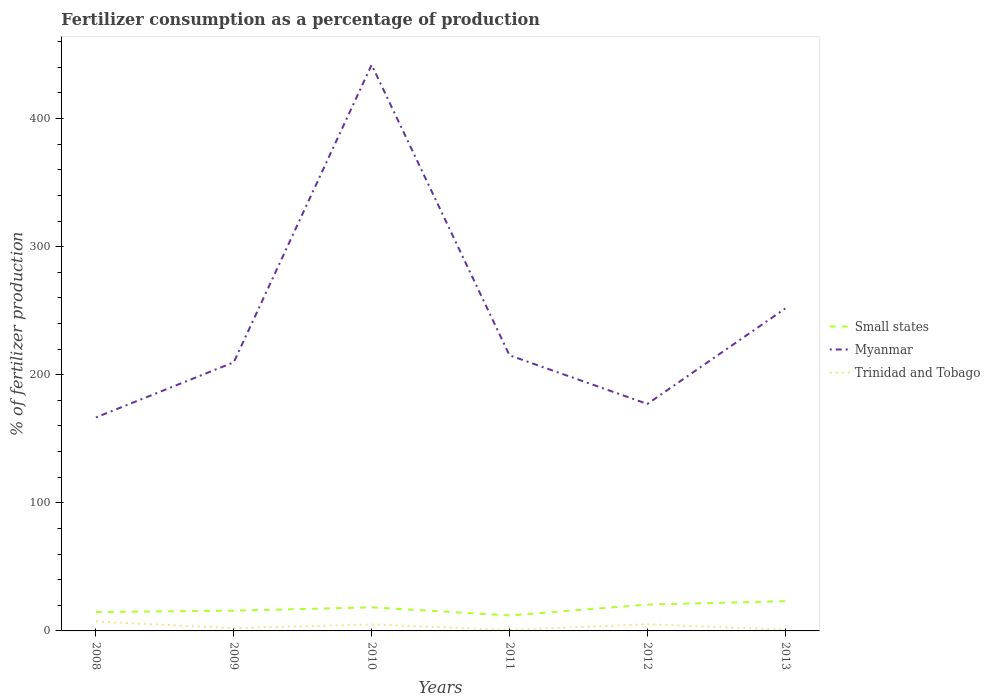How many different coloured lines are there?
Give a very brief answer. 3. Does the line corresponding to Trinidad and Tobago intersect with the line corresponding to Small states?
Your answer should be very brief. No. Is the number of lines equal to the number of legend labels?
Offer a very short reply. Yes. Across all years, what is the maximum percentage of fertilizers consumed in Myanmar?
Keep it short and to the point. 166.68. In which year was the percentage of fertilizers consumed in Small states maximum?
Provide a succinct answer. 2011. What is the total percentage of fertilizers consumed in Myanmar in the graph?
Provide a succinct answer. 32.51. What is the difference between the highest and the second highest percentage of fertilizers consumed in Trinidad and Tobago?
Offer a terse response. 6.61. Is the percentage of fertilizers consumed in Trinidad and Tobago strictly greater than the percentage of fertilizers consumed in Small states over the years?
Keep it short and to the point. Yes. How many years are there in the graph?
Your answer should be very brief. 6. What is the difference between two consecutive major ticks on the Y-axis?
Make the answer very short. 100. What is the title of the graph?
Make the answer very short. Fertilizer consumption as a percentage of production. What is the label or title of the Y-axis?
Offer a terse response. % of fertilizer production. What is the % of fertilizer production of Small states in 2008?
Make the answer very short. 14.71. What is the % of fertilizer production in Myanmar in 2008?
Keep it short and to the point. 166.68. What is the % of fertilizer production of Trinidad and Tobago in 2008?
Offer a very short reply. 7.37. What is the % of fertilizer production in Small states in 2009?
Keep it short and to the point. 15.83. What is the % of fertilizer production of Myanmar in 2009?
Your answer should be compact. 209.73. What is the % of fertilizer production in Trinidad and Tobago in 2009?
Keep it short and to the point. 2.14. What is the % of fertilizer production in Small states in 2010?
Provide a succinct answer. 18.43. What is the % of fertilizer production in Myanmar in 2010?
Your answer should be very brief. 441.98. What is the % of fertilizer production in Trinidad and Tobago in 2010?
Provide a succinct answer. 5.06. What is the % of fertilizer production of Small states in 2011?
Ensure brevity in your answer.  12.08. What is the % of fertilizer production in Myanmar in 2011?
Provide a short and direct response. 215.18. What is the % of fertilizer production in Trinidad and Tobago in 2011?
Your response must be concise. 0.76. What is the % of fertilizer production of Small states in 2012?
Your answer should be compact. 20.55. What is the % of fertilizer production of Myanmar in 2012?
Give a very brief answer. 177.22. What is the % of fertilizer production of Trinidad and Tobago in 2012?
Make the answer very short. 5.2. What is the % of fertilizer production of Small states in 2013?
Provide a short and direct response. 23.23. What is the % of fertilizer production of Myanmar in 2013?
Provide a succinct answer. 251.75. What is the % of fertilizer production in Trinidad and Tobago in 2013?
Offer a terse response. 0.95. Across all years, what is the maximum % of fertilizer production in Small states?
Ensure brevity in your answer.  23.23. Across all years, what is the maximum % of fertilizer production of Myanmar?
Ensure brevity in your answer.  441.98. Across all years, what is the maximum % of fertilizer production in Trinidad and Tobago?
Your response must be concise. 7.37. Across all years, what is the minimum % of fertilizer production in Small states?
Ensure brevity in your answer.  12.08. Across all years, what is the minimum % of fertilizer production in Myanmar?
Provide a succinct answer. 166.68. Across all years, what is the minimum % of fertilizer production in Trinidad and Tobago?
Your response must be concise. 0.76. What is the total % of fertilizer production in Small states in the graph?
Make the answer very short. 104.83. What is the total % of fertilizer production of Myanmar in the graph?
Your answer should be compact. 1462.53. What is the total % of fertilizer production of Trinidad and Tobago in the graph?
Keep it short and to the point. 21.49. What is the difference between the % of fertilizer production in Small states in 2008 and that in 2009?
Provide a short and direct response. -1.11. What is the difference between the % of fertilizer production in Myanmar in 2008 and that in 2009?
Provide a short and direct response. -43.05. What is the difference between the % of fertilizer production of Trinidad and Tobago in 2008 and that in 2009?
Your answer should be very brief. 5.23. What is the difference between the % of fertilizer production in Small states in 2008 and that in 2010?
Provide a short and direct response. -3.71. What is the difference between the % of fertilizer production of Myanmar in 2008 and that in 2010?
Your answer should be very brief. -275.3. What is the difference between the % of fertilizer production in Trinidad and Tobago in 2008 and that in 2010?
Provide a succinct answer. 2.31. What is the difference between the % of fertilizer production in Small states in 2008 and that in 2011?
Your answer should be compact. 2.64. What is the difference between the % of fertilizer production of Myanmar in 2008 and that in 2011?
Provide a succinct answer. -48.5. What is the difference between the % of fertilizer production of Trinidad and Tobago in 2008 and that in 2011?
Give a very brief answer. 6.61. What is the difference between the % of fertilizer production in Small states in 2008 and that in 2012?
Your answer should be compact. -5.84. What is the difference between the % of fertilizer production of Myanmar in 2008 and that in 2012?
Your answer should be compact. -10.54. What is the difference between the % of fertilizer production of Trinidad and Tobago in 2008 and that in 2012?
Your response must be concise. 2.17. What is the difference between the % of fertilizer production of Small states in 2008 and that in 2013?
Give a very brief answer. -8.52. What is the difference between the % of fertilizer production of Myanmar in 2008 and that in 2013?
Your answer should be very brief. -85.07. What is the difference between the % of fertilizer production of Trinidad and Tobago in 2008 and that in 2013?
Keep it short and to the point. 6.42. What is the difference between the % of fertilizer production of Small states in 2009 and that in 2010?
Your answer should be compact. -2.6. What is the difference between the % of fertilizer production of Myanmar in 2009 and that in 2010?
Your response must be concise. -232.25. What is the difference between the % of fertilizer production in Trinidad and Tobago in 2009 and that in 2010?
Provide a short and direct response. -2.91. What is the difference between the % of fertilizer production in Small states in 2009 and that in 2011?
Offer a terse response. 3.75. What is the difference between the % of fertilizer production of Myanmar in 2009 and that in 2011?
Your answer should be very brief. -5.45. What is the difference between the % of fertilizer production in Trinidad and Tobago in 2009 and that in 2011?
Ensure brevity in your answer.  1.38. What is the difference between the % of fertilizer production in Small states in 2009 and that in 2012?
Keep it short and to the point. -4.72. What is the difference between the % of fertilizer production in Myanmar in 2009 and that in 2012?
Your answer should be very brief. 32.51. What is the difference between the % of fertilizer production of Trinidad and Tobago in 2009 and that in 2012?
Keep it short and to the point. -3.05. What is the difference between the % of fertilizer production of Small states in 2009 and that in 2013?
Ensure brevity in your answer.  -7.4. What is the difference between the % of fertilizer production of Myanmar in 2009 and that in 2013?
Offer a terse response. -42.02. What is the difference between the % of fertilizer production in Trinidad and Tobago in 2009 and that in 2013?
Make the answer very short. 1.19. What is the difference between the % of fertilizer production in Small states in 2010 and that in 2011?
Provide a succinct answer. 6.35. What is the difference between the % of fertilizer production of Myanmar in 2010 and that in 2011?
Offer a terse response. 226.8. What is the difference between the % of fertilizer production in Trinidad and Tobago in 2010 and that in 2011?
Provide a succinct answer. 4.3. What is the difference between the % of fertilizer production in Small states in 2010 and that in 2012?
Your answer should be compact. -2.12. What is the difference between the % of fertilizer production of Myanmar in 2010 and that in 2012?
Provide a succinct answer. 264.76. What is the difference between the % of fertilizer production of Trinidad and Tobago in 2010 and that in 2012?
Give a very brief answer. -0.14. What is the difference between the % of fertilizer production of Small states in 2010 and that in 2013?
Keep it short and to the point. -4.8. What is the difference between the % of fertilizer production of Myanmar in 2010 and that in 2013?
Offer a very short reply. 190.23. What is the difference between the % of fertilizer production in Trinidad and Tobago in 2010 and that in 2013?
Provide a short and direct response. 4.1. What is the difference between the % of fertilizer production of Small states in 2011 and that in 2012?
Provide a succinct answer. -8.47. What is the difference between the % of fertilizer production in Myanmar in 2011 and that in 2012?
Make the answer very short. 37.96. What is the difference between the % of fertilizer production of Trinidad and Tobago in 2011 and that in 2012?
Your response must be concise. -4.44. What is the difference between the % of fertilizer production in Small states in 2011 and that in 2013?
Your response must be concise. -11.15. What is the difference between the % of fertilizer production of Myanmar in 2011 and that in 2013?
Your answer should be very brief. -36.57. What is the difference between the % of fertilizer production in Trinidad and Tobago in 2011 and that in 2013?
Your response must be concise. -0.19. What is the difference between the % of fertilizer production of Small states in 2012 and that in 2013?
Provide a succinct answer. -2.68. What is the difference between the % of fertilizer production of Myanmar in 2012 and that in 2013?
Keep it short and to the point. -74.53. What is the difference between the % of fertilizer production of Trinidad and Tobago in 2012 and that in 2013?
Offer a very short reply. 4.24. What is the difference between the % of fertilizer production of Small states in 2008 and the % of fertilizer production of Myanmar in 2009?
Provide a succinct answer. -195.01. What is the difference between the % of fertilizer production in Small states in 2008 and the % of fertilizer production in Trinidad and Tobago in 2009?
Offer a terse response. 12.57. What is the difference between the % of fertilizer production of Myanmar in 2008 and the % of fertilizer production of Trinidad and Tobago in 2009?
Your answer should be compact. 164.54. What is the difference between the % of fertilizer production of Small states in 2008 and the % of fertilizer production of Myanmar in 2010?
Give a very brief answer. -427.26. What is the difference between the % of fertilizer production in Small states in 2008 and the % of fertilizer production in Trinidad and Tobago in 2010?
Offer a terse response. 9.66. What is the difference between the % of fertilizer production of Myanmar in 2008 and the % of fertilizer production of Trinidad and Tobago in 2010?
Provide a succinct answer. 161.62. What is the difference between the % of fertilizer production in Small states in 2008 and the % of fertilizer production in Myanmar in 2011?
Your answer should be very brief. -200.46. What is the difference between the % of fertilizer production in Small states in 2008 and the % of fertilizer production in Trinidad and Tobago in 2011?
Give a very brief answer. 13.95. What is the difference between the % of fertilizer production in Myanmar in 2008 and the % of fertilizer production in Trinidad and Tobago in 2011?
Provide a short and direct response. 165.92. What is the difference between the % of fertilizer production of Small states in 2008 and the % of fertilizer production of Myanmar in 2012?
Give a very brief answer. -162.51. What is the difference between the % of fertilizer production of Small states in 2008 and the % of fertilizer production of Trinidad and Tobago in 2012?
Make the answer very short. 9.52. What is the difference between the % of fertilizer production of Myanmar in 2008 and the % of fertilizer production of Trinidad and Tobago in 2012?
Your answer should be very brief. 161.48. What is the difference between the % of fertilizer production in Small states in 2008 and the % of fertilizer production in Myanmar in 2013?
Your response must be concise. -237.03. What is the difference between the % of fertilizer production of Small states in 2008 and the % of fertilizer production of Trinidad and Tobago in 2013?
Make the answer very short. 13.76. What is the difference between the % of fertilizer production in Myanmar in 2008 and the % of fertilizer production in Trinidad and Tobago in 2013?
Provide a succinct answer. 165.73. What is the difference between the % of fertilizer production in Small states in 2009 and the % of fertilizer production in Myanmar in 2010?
Your answer should be compact. -426.15. What is the difference between the % of fertilizer production in Small states in 2009 and the % of fertilizer production in Trinidad and Tobago in 2010?
Provide a short and direct response. 10.77. What is the difference between the % of fertilizer production in Myanmar in 2009 and the % of fertilizer production in Trinidad and Tobago in 2010?
Your response must be concise. 204.67. What is the difference between the % of fertilizer production in Small states in 2009 and the % of fertilizer production in Myanmar in 2011?
Provide a succinct answer. -199.35. What is the difference between the % of fertilizer production in Small states in 2009 and the % of fertilizer production in Trinidad and Tobago in 2011?
Your response must be concise. 15.07. What is the difference between the % of fertilizer production of Myanmar in 2009 and the % of fertilizer production of Trinidad and Tobago in 2011?
Your answer should be very brief. 208.97. What is the difference between the % of fertilizer production in Small states in 2009 and the % of fertilizer production in Myanmar in 2012?
Ensure brevity in your answer.  -161.39. What is the difference between the % of fertilizer production of Small states in 2009 and the % of fertilizer production of Trinidad and Tobago in 2012?
Make the answer very short. 10.63. What is the difference between the % of fertilizer production of Myanmar in 2009 and the % of fertilizer production of Trinidad and Tobago in 2012?
Your answer should be compact. 204.53. What is the difference between the % of fertilizer production in Small states in 2009 and the % of fertilizer production in Myanmar in 2013?
Your answer should be very brief. -235.92. What is the difference between the % of fertilizer production of Small states in 2009 and the % of fertilizer production of Trinidad and Tobago in 2013?
Give a very brief answer. 14.87. What is the difference between the % of fertilizer production in Myanmar in 2009 and the % of fertilizer production in Trinidad and Tobago in 2013?
Your answer should be very brief. 208.77. What is the difference between the % of fertilizer production in Small states in 2010 and the % of fertilizer production in Myanmar in 2011?
Keep it short and to the point. -196.75. What is the difference between the % of fertilizer production in Small states in 2010 and the % of fertilizer production in Trinidad and Tobago in 2011?
Provide a succinct answer. 17.67. What is the difference between the % of fertilizer production of Myanmar in 2010 and the % of fertilizer production of Trinidad and Tobago in 2011?
Offer a very short reply. 441.22. What is the difference between the % of fertilizer production of Small states in 2010 and the % of fertilizer production of Myanmar in 2012?
Your answer should be compact. -158.79. What is the difference between the % of fertilizer production of Small states in 2010 and the % of fertilizer production of Trinidad and Tobago in 2012?
Make the answer very short. 13.23. What is the difference between the % of fertilizer production in Myanmar in 2010 and the % of fertilizer production in Trinidad and Tobago in 2012?
Provide a succinct answer. 436.78. What is the difference between the % of fertilizer production of Small states in 2010 and the % of fertilizer production of Myanmar in 2013?
Your answer should be compact. -233.32. What is the difference between the % of fertilizer production in Small states in 2010 and the % of fertilizer production in Trinidad and Tobago in 2013?
Offer a terse response. 17.47. What is the difference between the % of fertilizer production in Myanmar in 2010 and the % of fertilizer production in Trinidad and Tobago in 2013?
Provide a short and direct response. 441.02. What is the difference between the % of fertilizer production in Small states in 2011 and the % of fertilizer production in Myanmar in 2012?
Ensure brevity in your answer.  -165.14. What is the difference between the % of fertilizer production of Small states in 2011 and the % of fertilizer production of Trinidad and Tobago in 2012?
Your answer should be compact. 6.88. What is the difference between the % of fertilizer production in Myanmar in 2011 and the % of fertilizer production in Trinidad and Tobago in 2012?
Provide a succinct answer. 209.98. What is the difference between the % of fertilizer production in Small states in 2011 and the % of fertilizer production in Myanmar in 2013?
Make the answer very short. -239.67. What is the difference between the % of fertilizer production in Small states in 2011 and the % of fertilizer production in Trinidad and Tobago in 2013?
Offer a very short reply. 11.13. What is the difference between the % of fertilizer production of Myanmar in 2011 and the % of fertilizer production of Trinidad and Tobago in 2013?
Provide a succinct answer. 214.22. What is the difference between the % of fertilizer production of Small states in 2012 and the % of fertilizer production of Myanmar in 2013?
Provide a short and direct response. -231.19. What is the difference between the % of fertilizer production of Small states in 2012 and the % of fertilizer production of Trinidad and Tobago in 2013?
Your response must be concise. 19.6. What is the difference between the % of fertilizer production in Myanmar in 2012 and the % of fertilizer production in Trinidad and Tobago in 2013?
Provide a short and direct response. 176.27. What is the average % of fertilizer production of Small states per year?
Your answer should be very brief. 17.47. What is the average % of fertilizer production in Myanmar per year?
Your answer should be very brief. 243.75. What is the average % of fertilizer production of Trinidad and Tobago per year?
Provide a succinct answer. 3.58. In the year 2008, what is the difference between the % of fertilizer production of Small states and % of fertilizer production of Myanmar?
Provide a succinct answer. -151.96. In the year 2008, what is the difference between the % of fertilizer production in Small states and % of fertilizer production in Trinidad and Tobago?
Your answer should be compact. 7.34. In the year 2008, what is the difference between the % of fertilizer production of Myanmar and % of fertilizer production of Trinidad and Tobago?
Your response must be concise. 159.31. In the year 2009, what is the difference between the % of fertilizer production in Small states and % of fertilizer production in Myanmar?
Make the answer very short. -193.9. In the year 2009, what is the difference between the % of fertilizer production of Small states and % of fertilizer production of Trinidad and Tobago?
Your response must be concise. 13.68. In the year 2009, what is the difference between the % of fertilizer production of Myanmar and % of fertilizer production of Trinidad and Tobago?
Your answer should be compact. 207.58. In the year 2010, what is the difference between the % of fertilizer production in Small states and % of fertilizer production in Myanmar?
Your answer should be compact. -423.55. In the year 2010, what is the difference between the % of fertilizer production of Small states and % of fertilizer production of Trinidad and Tobago?
Your response must be concise. 13.37. In the year 2010, what is the difference between the % of fertilizer production in Myanmar and % of fertilizer production in Trinidad and Tobago?
Provide a short and direct response. 436.92. In the year 2011, what is the difference between the % of fertilizer production in Small states and % of fertilizer production in Myanmar?
Ensure brevity in your answer.  -203.1. In the year 2011, what is the difference between the % of fertilizer production of Small states and % of fertilizer production of Trinidad and Tobago?
Your answer should be compact. 11.32. In the year 2011, what is the difference between the % of fertilizer production in Myanmar and % of fertilizer production in Trinidad and Tobago?
Make the answer very short. 214.42. In the year 2012, what is the difference between the % of fertilizer production of Small states and % of fertilizer production of Myanmar?
Keep it short and to the point. -156.67. In the year 2012, what is the difference between the % of fertilizer production in Small states and % of fertilizer production in Trinidad and Tobago?
Keep it short and to the point. 15.36. In the year 2012, what is the difference between the % of fertilizer production of Myanmar and % of fertilizer production of Trinidad and Tobago?
Provide a succinct answer. 172.02. In the year 2013, what is the difference between the % of fertilizer production of Small states and % of fertilizer production of Myanmar?
Provide a short and direct response. -228.52. In the year 2013, what is the difference between the % of fertilizer production in Small states and % of fertilizer production in Trinidad and Tobago?
Your answer should be very brief. 22.28. In the year 2013, what is the difference between the % of fertilizer production of Myanmar and % of fertilizer production of Trinidad and Tobago?
Offer a terse response. 250.79. What is the ratio of the % of fertilizer production in Small states in 2008 to that in 2009?
Your answer should be very brief. 0.93. What is the ratio of the % of fertilizer production of Myanmar in 2008 to that in 2009?
Offer a very short reply. 0.79. What is the ratio of the % of fertilizer production of Trinidad and Tobago in 2008 to that in 2009?
Your response must be concise. 3.44. What is the ratio of the % of fertilizer production in Small states in 2008 to that in 2010?
Give a very brief answer. 0.8. What is the ratio of the % of fertilizer production in Myanmar in 2008 to that in 2010?
Your answer should be compact. 0.38. What is the ratio of the % of fertilizer production in Trinidad and Tobago in 2008 to that in 2010?
Provide a short and direct response. 1.46. What is the ratio of the % of fertilizer production of Small states in 2008 to that in 2011?
Ensure brevity in your answer.  1.22. What is the ratio of the % of fertilizer production of Myanmar in 2008 to that in 2011?
Give a very brief answer. 0.77. What is the ratio of the % of fertilizer production in Trinidad and Tobago in 2008 to that in 2011?
Your response must be concise. 9.68. What is the ratio of the % of fertilizer production in Small states in 2008 to that in 2012?
Keep it short and to the point. 0.72. What is the ratio of the % of fertilizer production in Myanmar in 2008 to that in 2012?
Ensure brevity in your answer.  0.94. What is the ratio of the % of fertilizer production of Trinidad and Tobago in 2008 to that in 2012?
Provide a succinct answer. 1.42. What is the ratio of the % of fertilizer production in Small states in 2008 to that in 2013?
Give a very brief answer. 0.63. What is the ratio of the % of fertilizer production of Myanmar in 2008 to that in 2013?
Offer a very short reply. 0.66. What is the ratio of the % of fertilizer production of Trinidad and Tobago in 2008 to that in 2013?
Your response must be concise. 7.72. What is the ratio of the % of fertilizer production in Small states in 2009 to that in 2010?
Make the answer very short. 0.86. What is the ratio of the % of fertilizer production of Myanmar in 2009 to that in 2010?
Your answer should be compact. 0.47. What is the ratio of the % of fertilizer production in Trinidad and Tobago in 2009 to that in 2010?
Offer a terse response. 0.42. What is the ratio of the % of fertilizer production of Small states in 2009 to that in 2011?
Offer a terse response. 1.31. What is the ratio of the % of fertilizer production in Myanmar in 2009 to that in 2011?
Provide a short and direct response. 0.97. What is the ratio of the % of fertilizer production of Trinidad and Tobago in 2009 to that in 2011?
Offer a terse response. 2.82. What is the ratio of the % of fertilizer production of Small states in 2009 to that in 2012?
Your answer should be compact. 0.77. What is the ratio of the % of fertilizer production in Myanmar in 2009 to that in 2012?
Provide a succinct answer. 1.18. What is the ratio of the % of fertilizer production in Trinidad and Tobago in 2009 to that in 2012?
Keep it short and to the point. 0.41. What is the ratio of the % of fertilizer production of Small states in 2009 to that in 2013?
Provide a short and direct response. 0.68. What is the ratio of the % of fertilizer production of Myanmar in 2009 to that in 2013?
Offer a terse response. 0.83. What is the ratio of the % of fertilizer production of Trinidad and Tobago in 2009 to that in 2013?
Provide a short and direct response. 2.25. What is the ratio of the % of fertilizer production of Small states in 2010 to that in 2011?
Offer a terse response. 1.53. What is the ratio of the % of fertilizer production of Myanmar in 2010 to that in 2011?
Provide a succinct answer. 2.05. What is the ratio of the % of fertilizer production in Trinidad and Tobago in 2010 to that in 2011?
Offer a very short reply. 6.65. What is the ratio of the % of fertilizer production of Small states in 2010 to that in 2012?
Keep it short and to the point. 0.9. What is the ratio of the % of fertilizer production of Myanmar in 2010 to that in 2012?
Offer a terse response. 2.49. What is the ratio of the % of fertilizer production in Trinidad and Tobago in 2010 to that in 2012?
Provide a short and direct response. 0.97. What is the ratio of the % of fertilizer production in Small states in 2010 to that in 2013?
Ensure brevity in your answer.  0.79. What is the ratio of the % of fertilizer production in Myanmar in 2010 to that in 2013?
Your answer should be compact. 1.76. What is the ratio of the % of fertilizer production in Trinidad and Tobago in 2010 to that in 2013?
Your response must be concise. 5.3. What is the ratio of the % of fertilizer production in Small states in 2011 to that in 2012?
Your response must be concise. 0.59. What is the ratio of the % of fertilizer production in Myanmar in 2011 to that in 2012?
Offer a very short reply. 1.21. What is the ratio of the % of fertilizer production in Trinidad and Tobago in 2011 to that in 2012?
Your answer should be very brief. 0.15. What is the ratio of the % of fertilizer production of Small states in 2011 to that in 2013?
Provide a short and direct response. 0.52. What is the ratio of the % of fertilizer production of Myanmar in 2011 to that in 2013?
Keep it short and to the point. 0.85. What is the ratio of the % of fertilizer production in Trinidad and Tobago in 2011 to that in 2013?
Ensure brevity in your answer.  0.8. What is the ratio of the % of fertilizer production of Small states in 2012 to that in 2013?
Ensure brevity in your answer.  0.88. What is the ratio of the % of fertilizer production of Myanmar in 2012 to that in 2013?
Provide a short and direct response. 0.7. What is the ratio of the % of fertilizer production of Trinidad and Tobago in 2012 to that in 2013?
Offer a terse response. 5.44. What is the difference between the highest and the second highest % of fertilizer production of Small states?
Provide a succinct answer. 2.68. What is the difference between the highest and the second highest % of fertilizer production of Myanmar?
Provide a succinct answer. 190.23. What is the difference between the highest and the second highest % of fertilizer production in Trinidad and Tobago?
Give a very brief answer. 2.17. What is the difference between the highest and the lowest % of fertilizer production in Small states?
Offer a terse response. 11.15. What is the difference between the highest and the lowest % of fertilizer production in Myanmar?
Offer a very short reply. 275.3. What is the difference between the highest and the lowest % of fertilizer production in Trinidad and Tobago?
Ensure brevity in your answer.  6.61. 